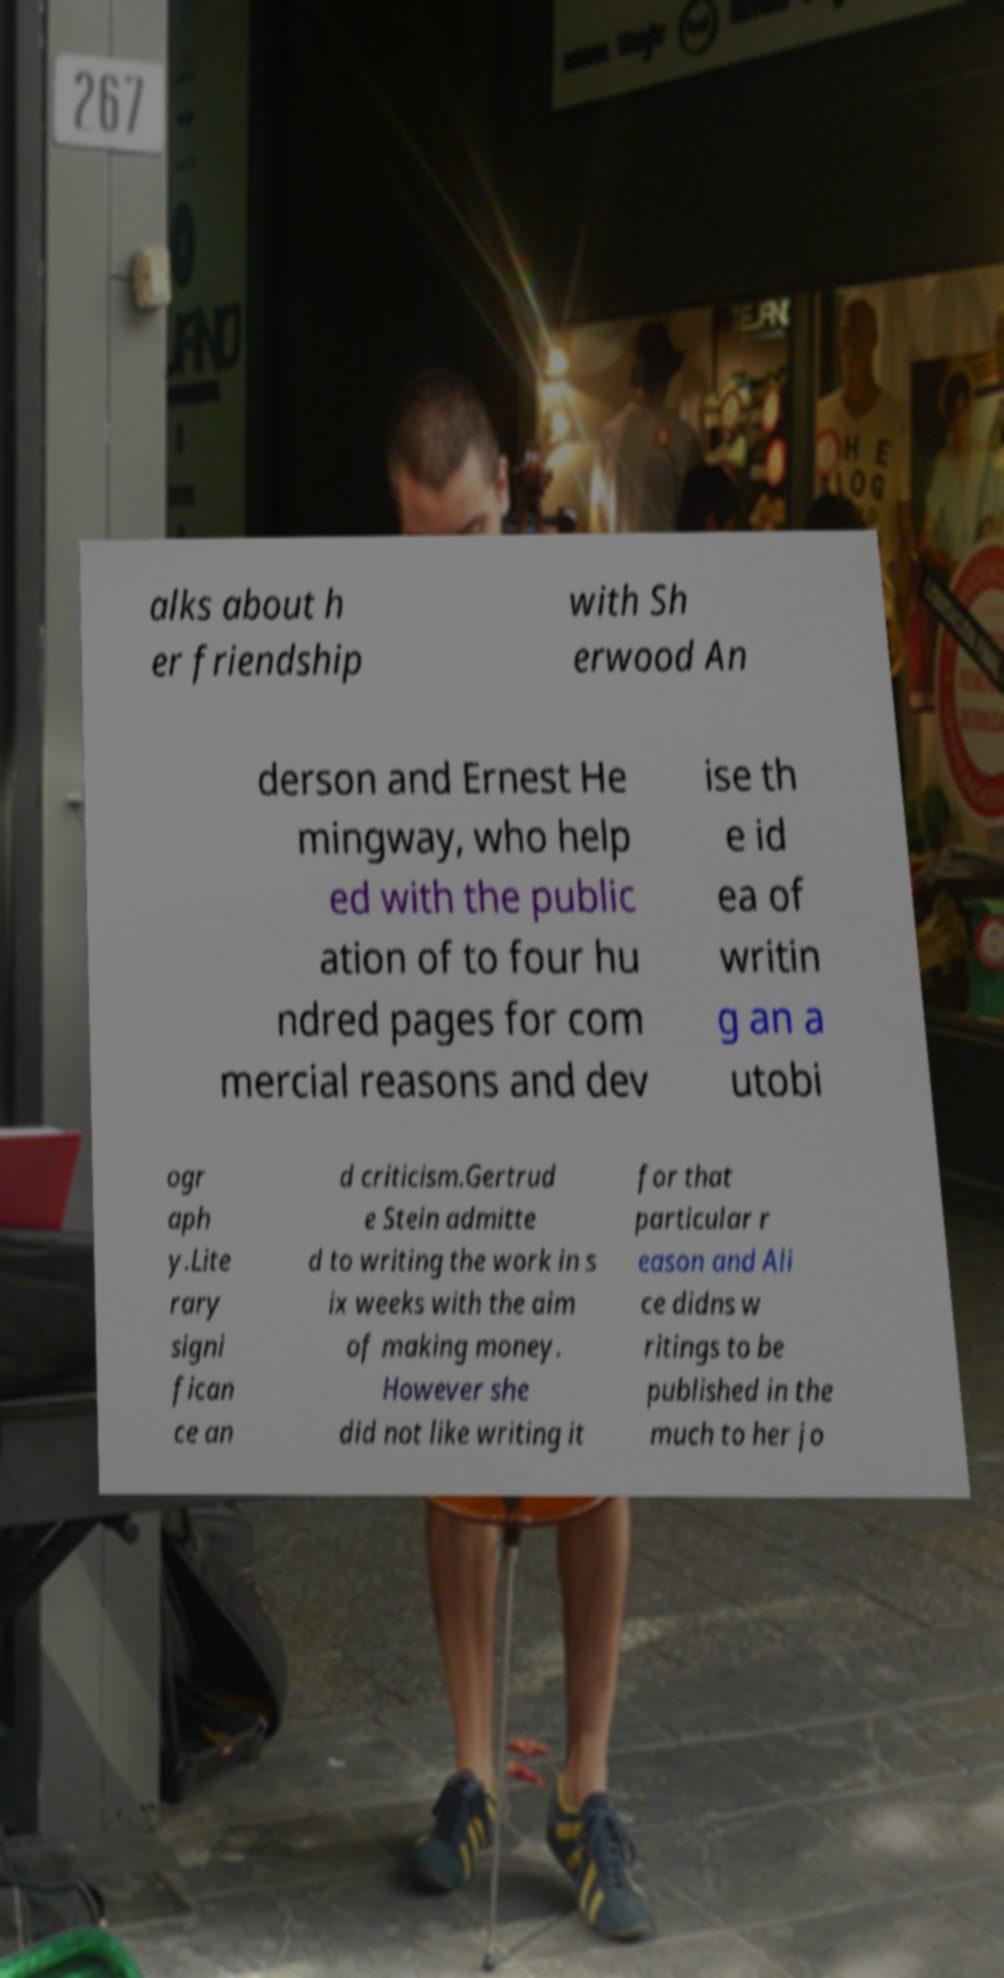Please identify and transcribe the text found in this image. alks about h er friendship with Sh erwood An derson and Ernest He mingway, who help ed with the public ation of to four hu ndred pages for com mercial reasons and dev ise th e id ea of writin g an a utobi ogr aph y.Lite rary signi fican ce an d criticism.Gertrud e Stein admitte d to writing the work in s ix weeks with the aim of making money. However she did not like writing it for that particular r eason and Ali ce didns w ritings to be published in the much to her jo 